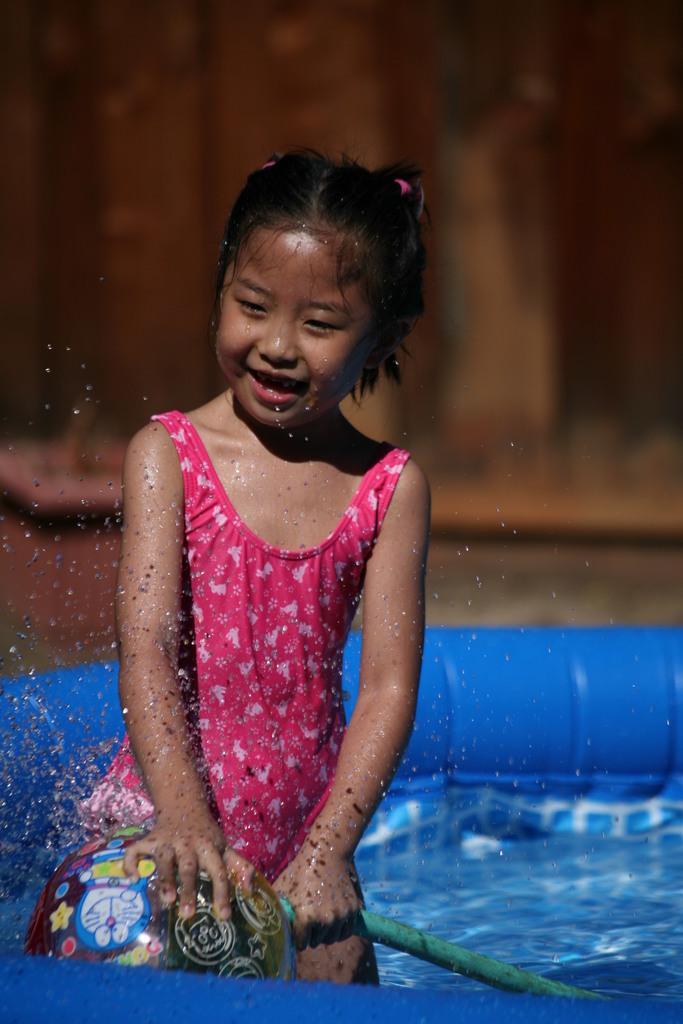Could you give a brief overview of what you see in this image? In the middle of the image a girl is standing in the water balloon and holding a balloon and smiling. Background of the image is blur. 